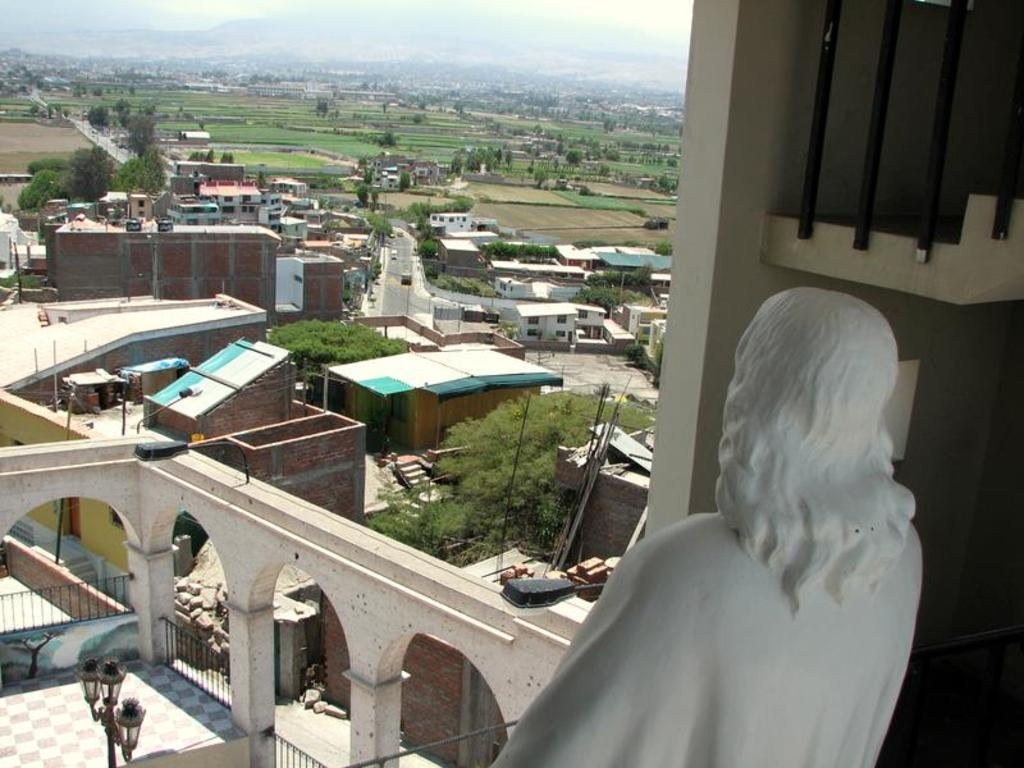What type of structures can be seen in the image? There are many buildings in the image. What natural elements are present in the image? There are trees in the image. What man-made object can be seen separating areas in the image? There is a fence in the image. What type of street furniture is visible in the image? There is a light pole in the image. What artistic element can be found in the image? There is a sculpture in the image. What is the color of the sculpture? The sculpture is white in color. What type of material is visible in the image? There are bricks in the image. What part of the natural environment is visible in the image? The sky is visible in the image. Where is the doctor's office located in the image? There is no doctor's office present in the image. What type of road can be seen in the image? There is no road visible in the image. 